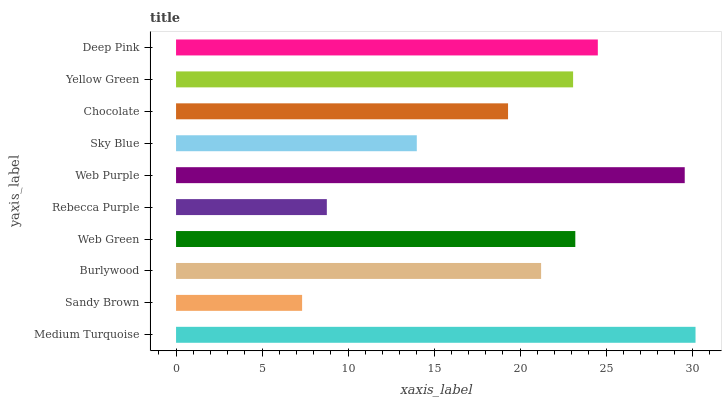Is Sandy Brown the minimum?
Answer yes or no. Yes. Is Medium Turquoise the maximum?
Answer yes or no. Yes. Is Burlywood the minimum?
Answer yes or no. No. Is Burlywood the maximum?
Answer yes or no. No. Is Burlywood greater than Sandy Brown?
Answer yes or no. Yes. Is Sandy Brown less than Burlywood?
Answer yes or no. Yes. Is Sandy Brown greater than Burlywood?
Answer yes or no. No. Is Burlywood less than Sandy Brown?
Answer yes or no. No. Is Yellow Green the high median?
Answer yes or no. Yes. Is Burlywood the low median?
Answer yes or no. Yes. Is Deep Pink the high median?
Answer yes or no. No. Is Deep Pink the low median?
Answer yes or no. No. 